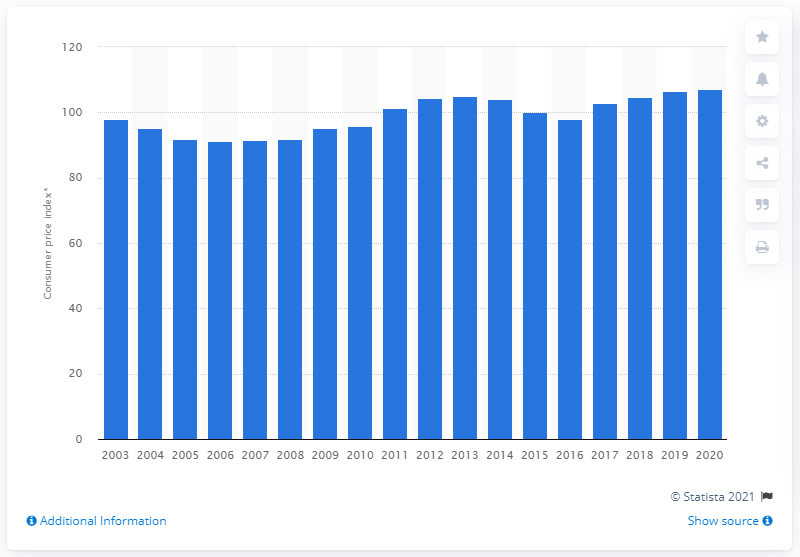Indicate a few pertinent items in this graphic. In 2020, the price index value of beer was 107.1. 